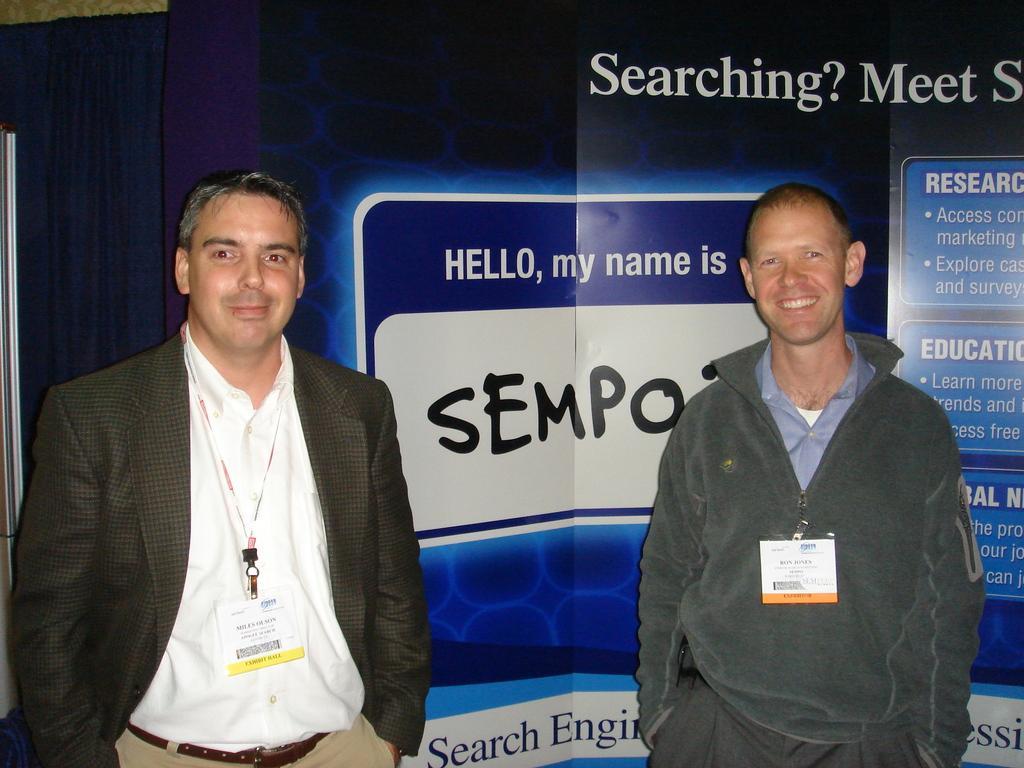In one or two sentences, can you explain what this image depicts? On the left side of the image we can see a person is standing and wearing a white color dress. In the middle of the image we can see a banner on which some text was written. On the left side of the image we can see a person is standing and wearing ash color dress. 